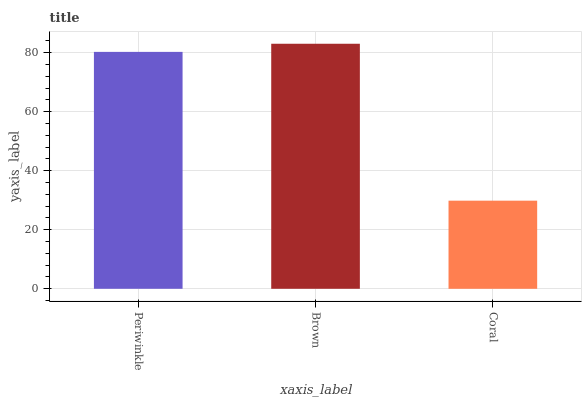Is Coral the minimum?
Answer yes or no. Yes. Is Brown the maximum?
Answer yes or no. Yes. Is Brown the minimum?
Answer yes or no. No. Is Coral the maximum?
Answer yes or no. No. Is Brown greater than Coral?
Answer yes or no. Yes. Is Coral less than Brown?
Answer yes or no. Yes. Is Coral greater than Brown?
Answer yes or no. No. Is Brown less than Coral?
Answer yes or no. No. Is Periwinkle the high median?
Answer yes or no. Yes. Is Periwinkle the low median?
Answer yes or no. Yes. Is Brown the high median?
Answer yes or no. No. Is Coral the low median?
Answer yes or no. No. 